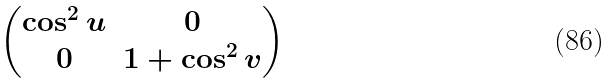Convert formula to latex. <formula><loc_0><loc_0><loc_500><loc_500>\begin{pmatrix} \cos ^ { 2 } u & 0 \\ 0 & 1 + \cos ^ { 2 } v \end{pmatrix}</formula> 